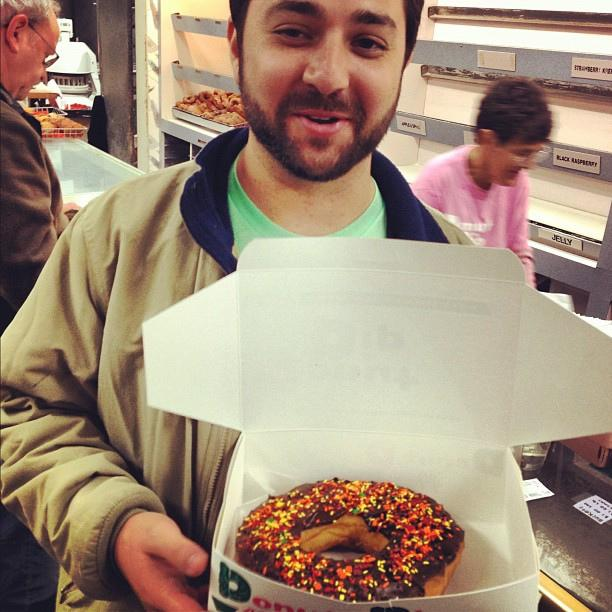What food nutrients are lacking in this food? Please explain your reasoning. fiber. The nutrients lack fiber. 